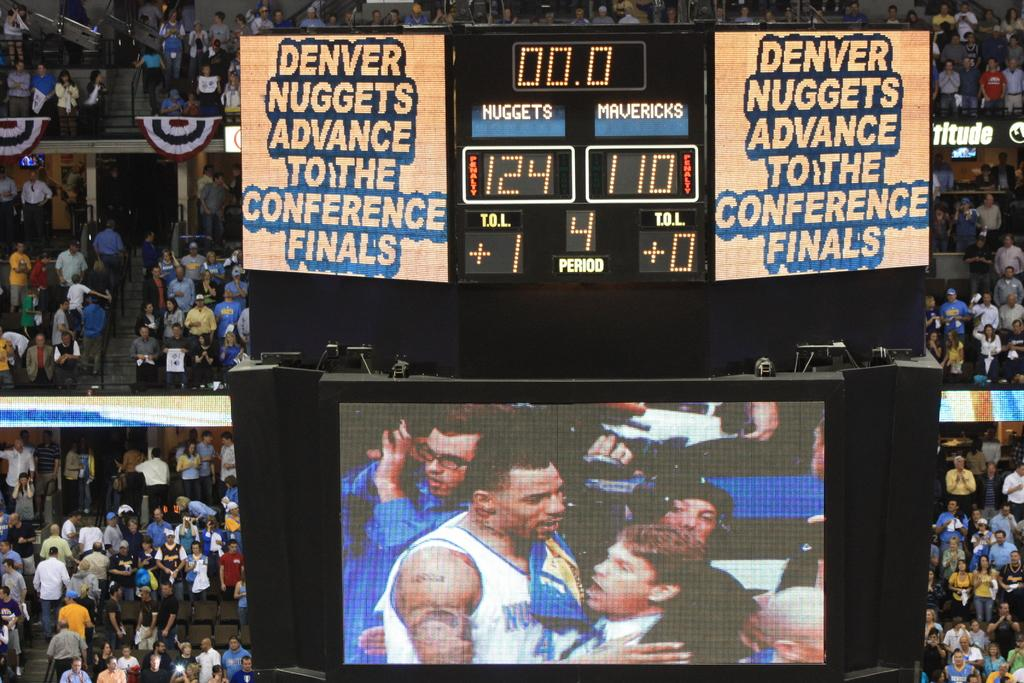<image>
Describe the image concisely. the score on the clock is 124 to 110 